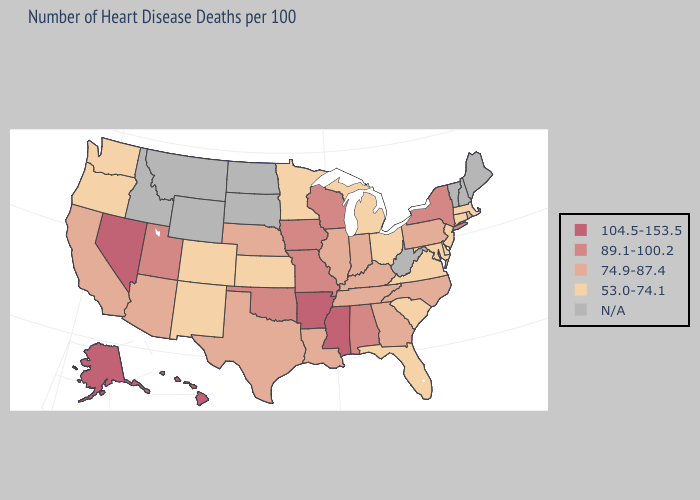Is the legend a continuous bar?
Concise answer only. No. Does the map have missing data?
Short answer required. Yes. Does Nevada have the highest value in the West?
Write a very short answer. Yes. Does Iowa have the lowest value in the USA?
Keep it brief. No. Name the states that have a value in the range N/A?
Concise answer only. Idaho, Maine, Montana, New Hampshire, North Dakota, South Dakota, Vermont, West Virginia, Wyoming. What is the value of Arizona?
Answer briefly. 74.9-87.4. What is the value of New Jersey?
Be succinct. 53.0-74.1. What is the lowest value in states that border Oregon?
Concise answer only. 53.0-74.1. Among the states that border Alabama , does Tennessee have the highest value?
Be succinct. No. What is the value of Delaware?
Quick response, please. 53.0-74.1. Does Oregon have the highest value in the West?
Be succinct. No. Name the states that have a value in the range 104.5-153.5?
Write a very short answer. Alaska, Arkansas, Hawaii, Mississippi, Nevada. What is the value of Virginia?
Short answer required. 53.0-74.1. What is the value of Alaska?
Quick response, please. 104.5-153.5. 